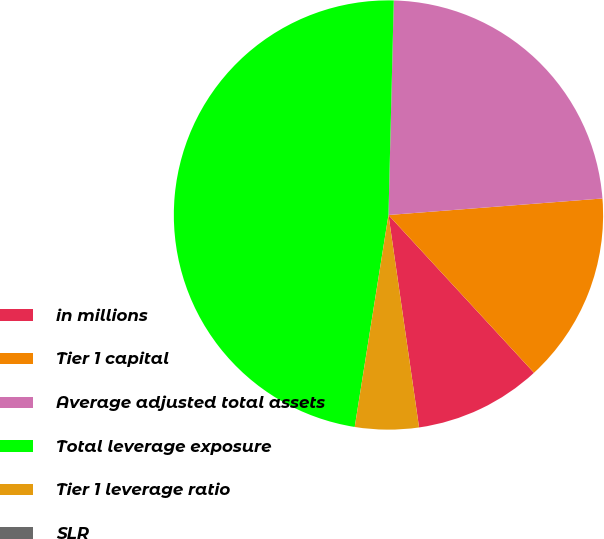<chart> <loc_0><loc_0><loc_500><loc_500><pie_chart><fcel>in millions<fcel>Tier 1 capital<fcel>Average adjusted total assets<fcel>Total leverage exposure<fcel>Tier 1 leverage ratio<fcel>SLR<nl><fcel>9.58%<fcel>14.37%<fcel>23.38%<fcel>47.88%<fcel>4.79%<fcel>0.0%<nl></chart> 